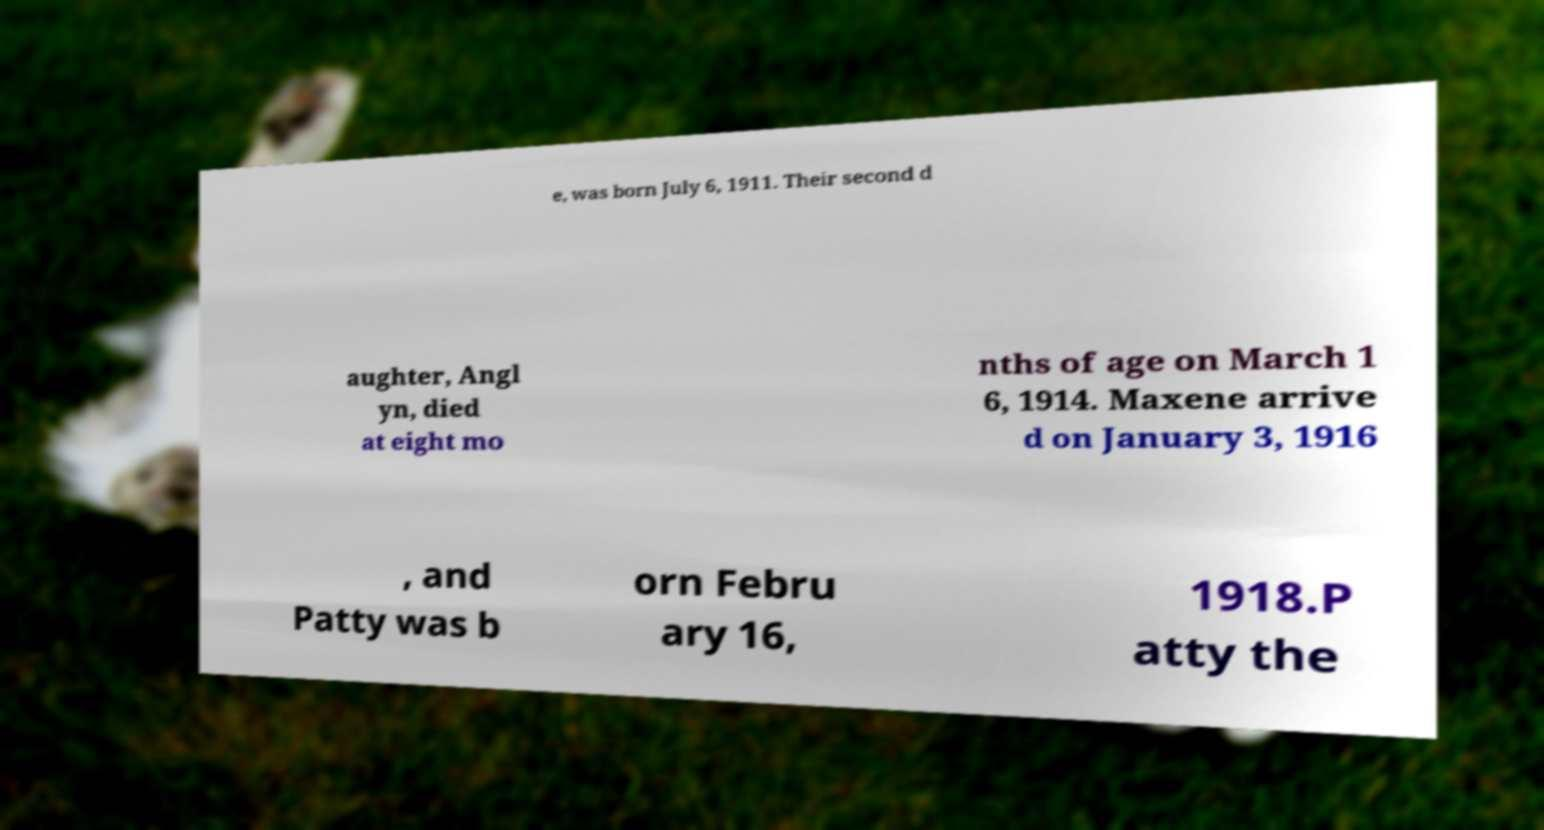What messages or text are displayed in this image? I need them in a readable, typed format. e, was born July 6, 1911. Their second d aughter, Angl yn, died at eight mo nths of age on March 1 6, 1914. Maxene arrive d on January 3, 1916 , and Patty was b orn Febru ary 16, 1918.P atty the 